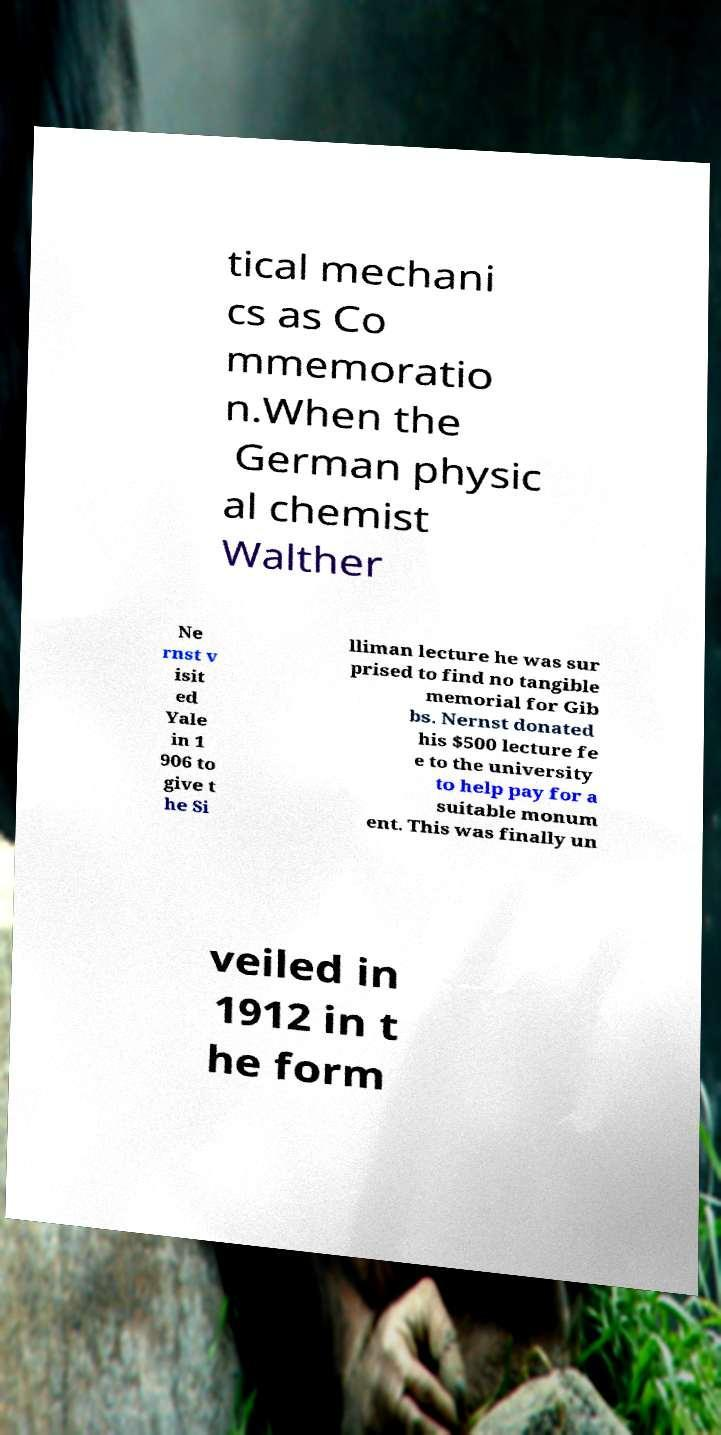What messages or text are displayed in this image? I need them in a readable, typed format. tical mechani cs as Co mmemoratio n.When the German physic al chemist Walther Ne rnst v isit ed Yale in 1 906 to give t he Si lliman lecture he was sur prised to find no tangible memorial for Gib bs. Nernst donated his $500 lecture fe e to the university to help pay for a suitable monum ent. This was finally un veiled in 1912 in t he form 